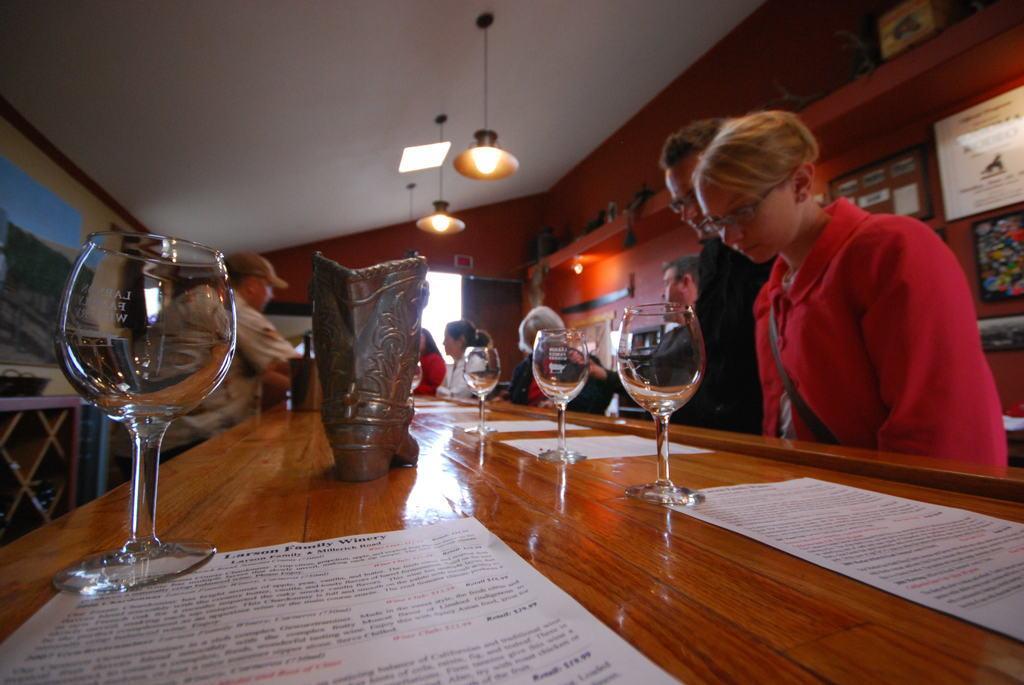Could you give a brief overview of what you see in this image? This picture is taken in a restaurant. In the center there is a table, on the table there are glasses and papers. Towards the right there are two persons, one man and one woman. Woman is wearing red and man is wearing black. In the center there are group of people. In the top there are two lights. In the right corner there are some frames. 